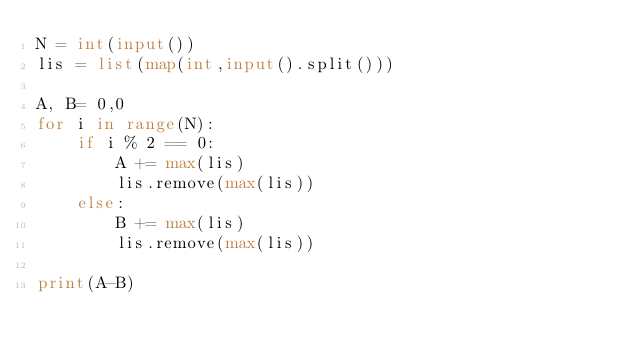<code> <loc_0><loc_0><loc_500><loc_500><_Python_>N = int(input())
lis = list(map(int,input().split()))

A, B= 0,0
for i in range(N):
    if i % 2 == 0:
        A += max(lis)
        lis.remove(max(lis))
    else:
        B += max(lis)
        lis.remove(max(lis))

print(A-B)</code> 